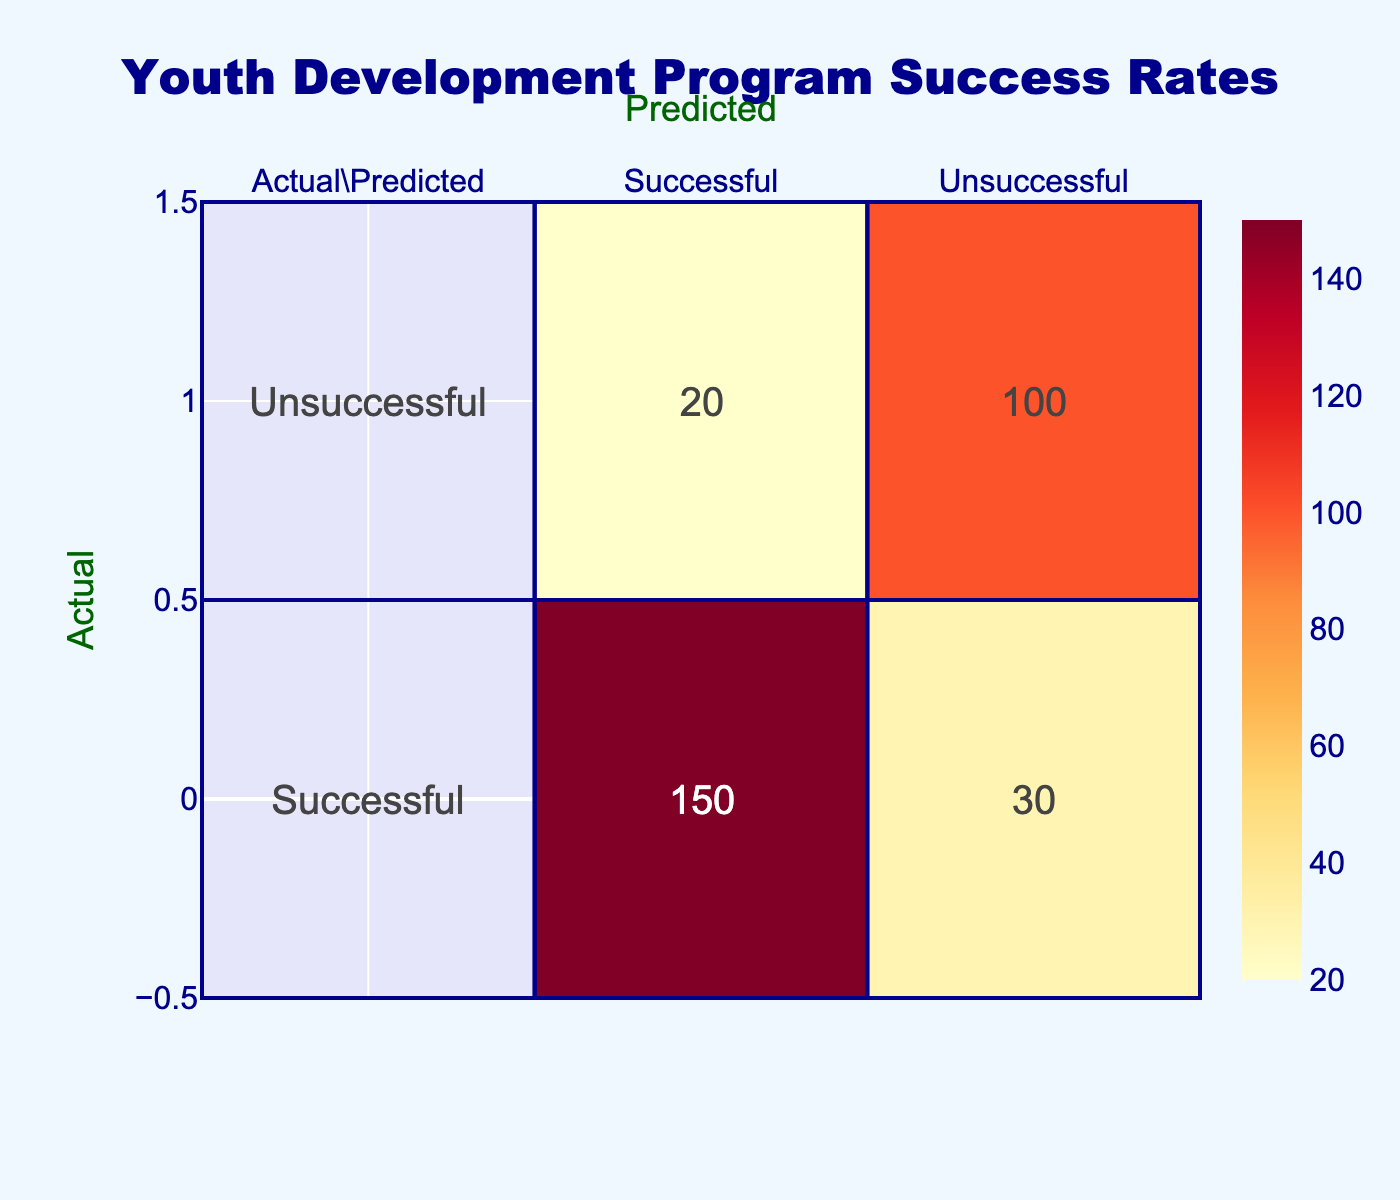What is the total number of successful predictions? In the confusion matrix, the successful predictions are represented in the first row under the "Successful" column. This value is 150.
Answer: 150 What percentage of actual successes were predicted successfully? To find this percentage, divide the successful predictions (150) by the total actual successes (150 + 30 = 180). Calculate as (150 / 180) * 100, which equals approximately 83.33%.
Answer: 83.33% How many actual unsuccessful cases were correctly classified as unsuccessful? Looking at the confusion matrix, the value in the "Unsuccessful" row under the "Unsuccessful" column is 100. This is the number of actual unsuccessful cases that were predicted correctly.
Answer: 100 What is the total number of predictions made? The total predictions include both successful and unsuccessful predictions. This can be found by summing all the values in the matrix: (150 + 30 + 20 + 100) = 300.
Answer: 300 Is the number of successful predictions greater than the number of unsuccessful predictions? Yes, when comparing the successful predictions (150) to the unsuccessful predictions (30 + 100 = 130), we see that 150 is greater than 130.
Answer: Yes What is the difference between the actual successful cases and the predicted successful cases? The actual successful cases total 180, while the predicted successful cases total 150. The difference is calculated as 180 - 150 = 30.
Answer: 30 If the prediction model were perfect, how many total mistakes would it make? A perfect prediction model would make zero mistakes. The matrix shows 30 incorrect successful predictions and 20 incorrect unsuccessful predictions, totaling 50 mistakes.
Answer: 50 What is the sensitivity of the model? Sensitivity, or true positive rate, is calculated by dividing the number of true positives (150) by the total actual positives (180). This is (150 / 180) * 100, which is approximately 83.33%.
Answer: 83.33% What proportion of predicted unsuccessful cases were actually unsuccessful? The predicted unsuccessful cases comprise both true negatives (100) and false negatives (20), making the total predicted unsuccessful cases 120. The proportion is calculated as 100 / 120 = 0.8333, or 83.33%.
Answer: 83.33% 